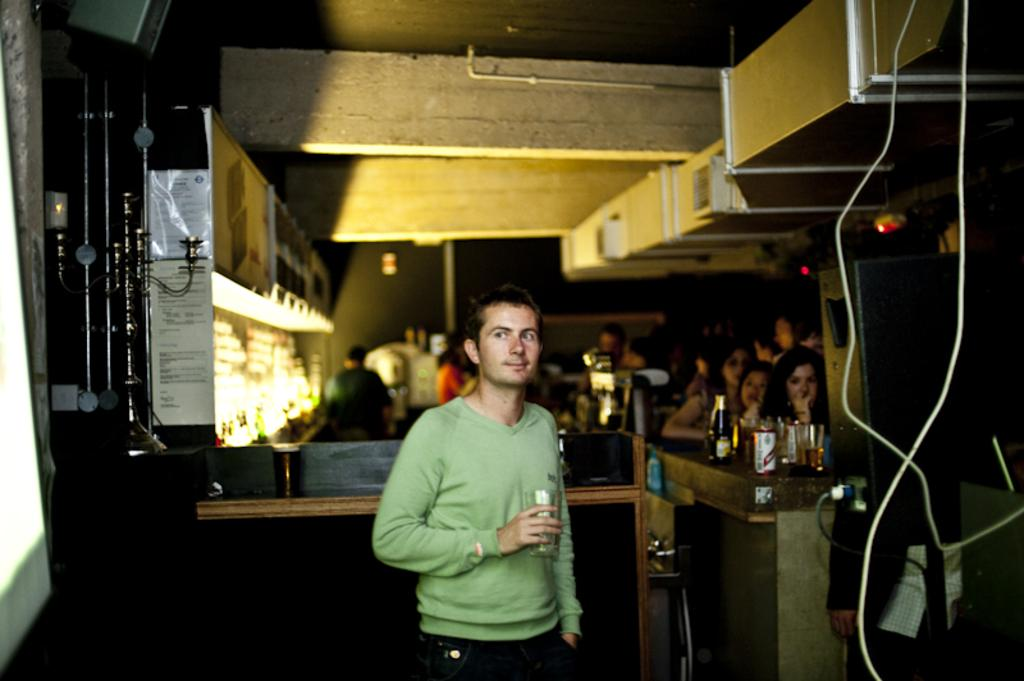What is the person in the image holding? The person in the image is holding a glass. What other objects related to beverages can be seen in the image? There are bottles and glasses in the image. What type of decorations are present in the image? There are posters in the image. What kind of lighting is visible in the image? There are lights in the image. How many people are present in the image? There are people in the image. What is the background of the image composed of? There is a wall in the background of the image. What type of fork can be seen in the image? There is no fork present in the image. What season is depicted in the image? The image does not depict a specific season, so it cannot be determined from the image. 